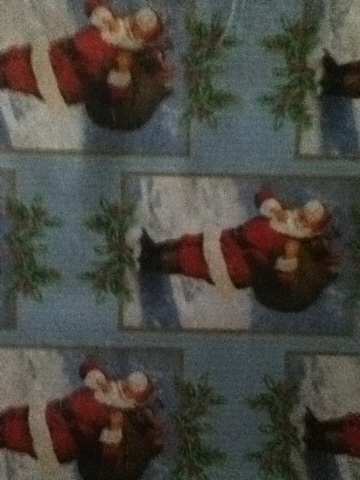Imagine the scene where this image is taken from; can you create a vivid description of it? Imagine a cozy living room adorned with twinkling lights and festive decorations. The scent of pine fills the air from a beautifully decorated Christmas tree standing tall in the corner. Presents wrapped in various types of festive paper, including the one with Santa Claus, are stacked under the tree. A fireplace crackles softly, adding warmth to the room, and stockings hang from the mantelpiece. Outside, snow gently falls, covering the world in a serene white blanket. Laughter and the sound of holiday music echo through the house, creating a joyful and peaceful atmosphere. 